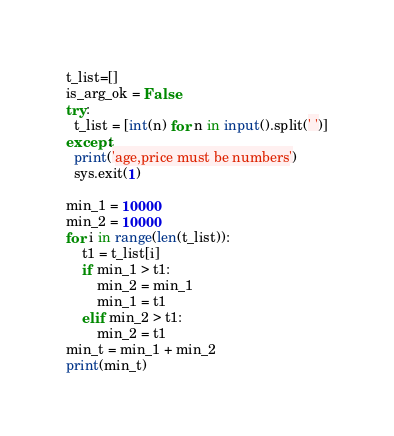<code> <loc_0><loc_0><loc_500><loc_500><_Python_>t_list=[]
is_arg_ok = False
try:
  t_list = [int(n) for n in input().split(' ')]
except:
  print('age,price must be numbers')
  sys.exit(1)

min_1 = 10000
min_2 = 10000
for i in range(len(t_list)):
    t1 = t_list[i]
    if min_1 > t1:
        min_2 = min_1
        min_1 = t1
    elif min_2 > t1:
        min_2 = t1
min_t = min_1 + min_2
print(min_t)</code> 